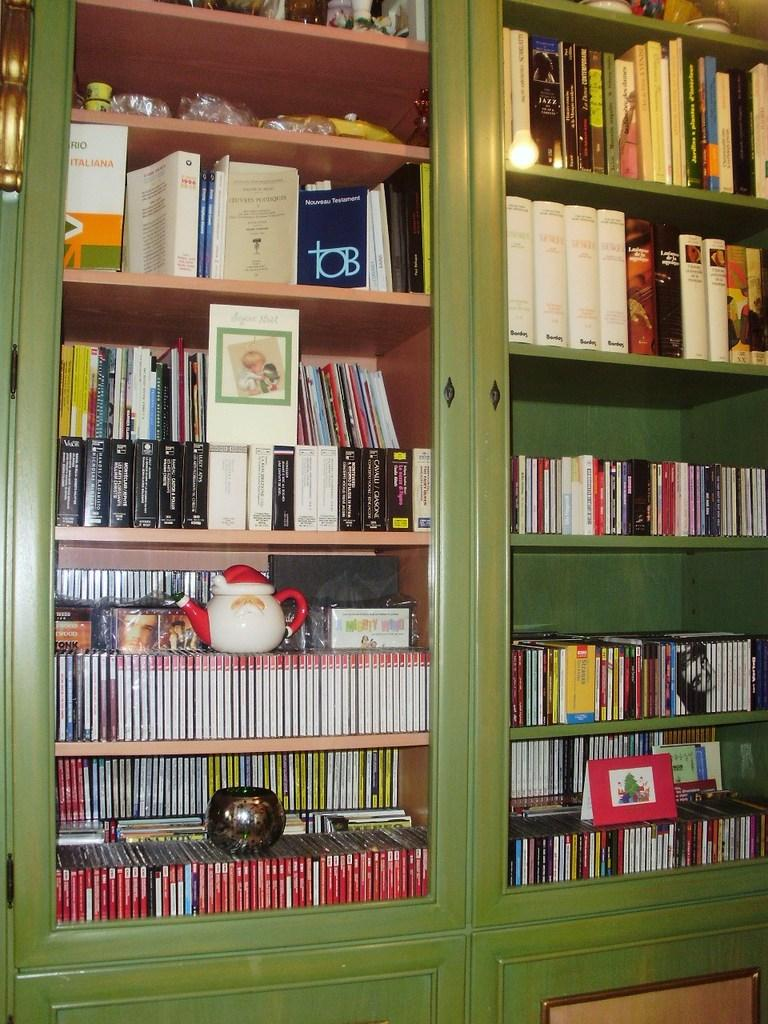<image>
Create a compact narrative representing the image presented. A book with TOB on the front of it. 